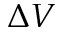<formula> <loc_0><loc_0><loc_500><loc_500>\Delta V</formula> 